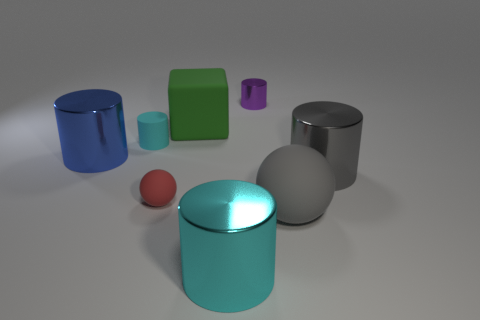Subtract all large cyan cylinders. How many cylinders are left? 4 Subtract all cylinders. How many objects are left? 3 Subtract all gray cylinders. How many cylinders are left? 4 Subtract 0 red blocks. How many objects are left? 8 Subtract 1 balls. How many balls are left? 1 Subtract all brown blocks. Subtract all green spheres. How many blocks are left? 1 Subtract all gray cylinders. How many purple cubes are left? 0 Subtract all purple cylinders. Subtract all small red metallic cylinders. How many objects are left? 7 Add 7 large green matte cubes. How many large green matte cubes are left? 8 Add 2 tiny rubber balls. How many tiny rubber balls exist? 3 